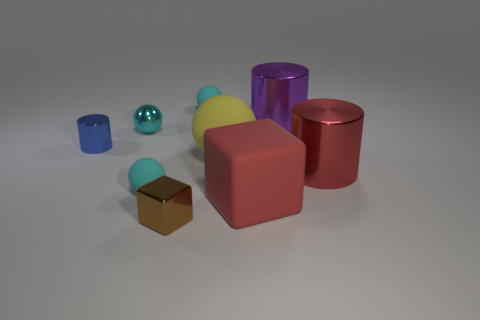The matte object that is to the left of the tiny metal object that is in front of the large matte cube is what shape?
Provide a succinct answer. Sphere. Are there any matte cylinders that have the same size as the brown thing?
Give a very brief answer. No. What number of cyan objects have the same shape as the yellow thing?
Make the answer very short. 3. Are there the same number of cyan objects in front of the small blue object and cylinders that are in front of the big yellow thing?
Make the answer very short. Yes. Is there a big cyan object?
Your response must be concise. No. What size is the yellow rubber ball that is to the right of the tiny metallic thing behind the cylinder on the left side of the large red cube?
Your answer should be very brief. Large. What shape is the yellow rubber object that is the same size as the red block?
Provide a short and direct response. Sphere. How many things are either spheres that are behind the yellow rubber thing or yellow things?
Ensure brevity in your answer.  3. Is there a purple metal cylinder to the left of the cyan matte thing on the left side of the small cyan object that is right of the brown metallic block?
Your response must be concise. No. How many blocks are there?
Offer a terse response. 2. 